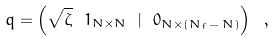Convert formula to latex. <formula><loc_0><loc_0><loc_500><loc_500>q = \left ( \sqrt { \zeta } \ { 1 } _ { N \times N } \ | \ { 0 } _ { N \times ( N _ { f } \, - \, N ) } \right ) \ ,</formula> 